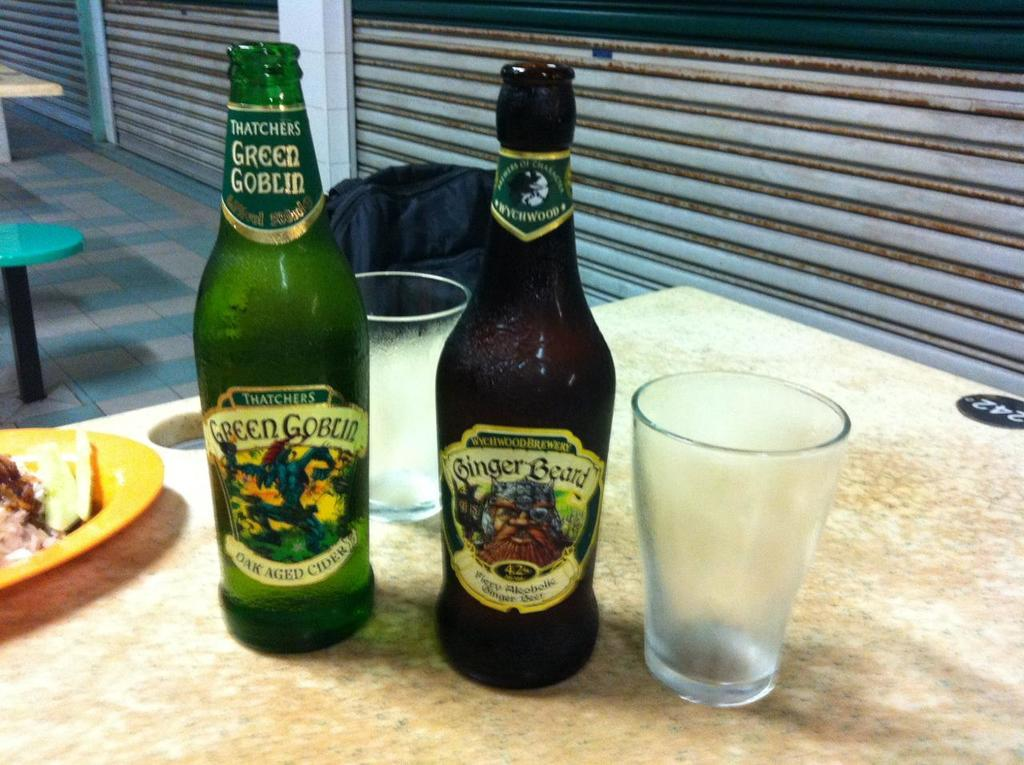Provide a one-sentence caption for the provided image. A bottle of Green Goblin is on a counter next to another bottle of beer. 